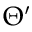Convert formula to latex. <formula><loc_0><loc_0><loc_500><loc_500>\Theta ^ { \prime }</formula> 